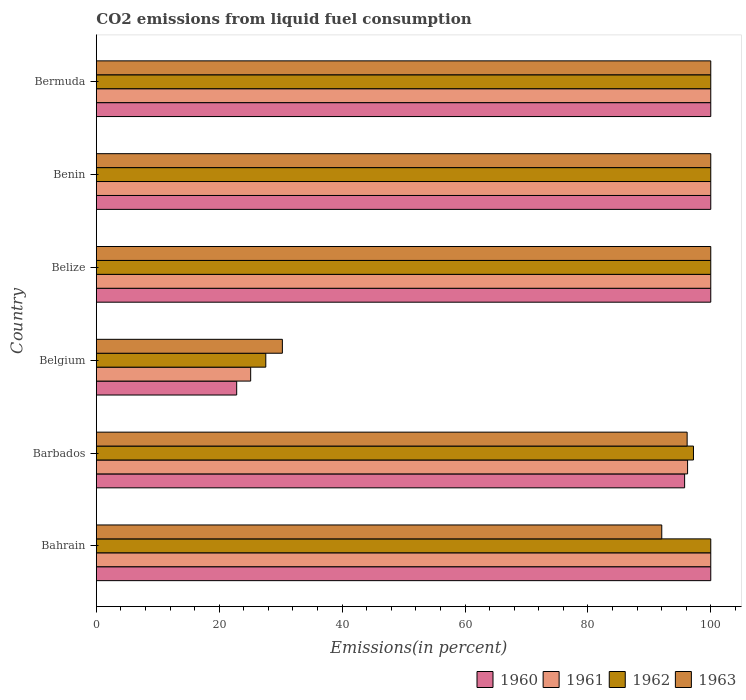How many groups of bars are there?
Your answer should be very brief. 6. Are the number of bars per tick equal to the number of legend labels?
Your answer should be very brief. Yes. Are the number of bars on each tick of the Y-axis equal?
Keep it short and to the point. Yes. How many bars are there on the 3rd tick from the bottom?
Make the answer very short. 4. What is the label of the 1st group of bars from the top?
Ensure brevity in your answer.  Bermuda. What is the total CO2 emitted in 1963 in Belgium?
Give a very brief answer. 30.28. Across all countries, what is the maximum total CO2 emitted in 1962?
Provide a succinct answer. 100. Across all countries, what is the minimum total CO2 emitted in 1961?
Your response must be concise. 25.12. In which country was the total CO2 emitted in 1961 maximum?
Make the answer very short. Bahrain. In which country was the total CO2 emitted in 1960 minimum?
Your response must be concise. Belgium. What is the total total CO2 emitted in 1963 in the graph?
Give a very brief answer. 518.46. What is the difference between the total CO2 emitted in 1961 in Barbados and that in Benin?
Your answer should be very brief. -3.77. What is the difference between the total CO2 emitted in 1961 in Bahrain and the total CO2 emitted in 1963 in Belgium?
Your answer should be compact. 69.72. What is the average total CO2 emitted in 1962 per country?
Provide a succinct answer. 87.46. What is the difference between the total CO2 emitted in 1960 and total CO2 emitted in 1963 in Belize?
Your answer should be compact. 0. In how many countries, is the total CO2 emitted in 1963 greater than 60 %?
Your answer should be compact. 5. What is the ratio of the total CO2 emitted in 1960 in Bahrain to that in Benin?
Offer a terse response. 1. Is the total CO2 emitted in 1960 in Belgium less than that in Belize?
Your answer should be very brief. Yes. Is the difference between the total CO2 emitted in 1960 in Bahrain and Belize greater than the difference between the total CO2 emitted in 1963 in Bahrain and Belize?
Keep it short and to the point. Yes. What is the difference between the highest and the second highest total CO2 emitted in 1960?
Make the answer very short. 0. What is the difference between the highest and the lowest total CO2 emitted in 1963?
Your answer should be compact. 69.72. In how many countries, is the total CO2 emitted in 1960 greater than the average total CO2 emitted in 1960 taken over all countries?
Offer a very short reply. 5. Is the sum of the total CO2 emitted in 1962 in Barbados and Belgium greater than the maximum total CO2 emitted in 1961 across all countries?
Offer a terse response. Yes. Is it the case that in every country, the sum of the total CO2 emitted in 1960 and total CO2 emitted in 1961 is greater than the sum of total CO2 emitted in 1963 and total CO2 emitted in 1962?
Make the answer very short. No. How many bars are there?
Your answer should be very brief. 24. Are the values on the major ticks of X-axis written in scientific E-notation?
Provide a succinct answer. No. Where does the legend appear in the graph?
Your answer should be very brief. Bottom right. How many legend labels are there?
Offer a terse response. 4. What is the title of the graph?
Offer a very short reply. CO2 emissions from liquid fuel consumption. What is the label or title of the X-axis?
Ensure brevity in your answer.  Emissions(in percent). What is the label or title of the Y-axis?
Give a very brief answer. Country. What is the Emissions(in percent) in 1960 in Bahrain?
Your answer should be very brief. 100. What is the Emissions(in percent) of 1961 in Bahrain?
Make the answer very short. 100. What is the Emissions(in percent) of 1962 in Bahrain?
Make the answer very short. 100. What is the Emissions(in percent) of 1963 in Bahrain?
Give a very brief answer. 92.02. What is the Emissions(in percent) in 1960 in Barbados?
Offer a terse response. 95.74. What is the Emissions(in percent) of 1961 in Barbados?
Keep it short and to the point. 96.23. What is the Emissions(in percent) of 1962 in Barbados?
Give a very brief answer. 97.18. What is the Emissions(in percent) of 1963 in Barbados?
Your response must be concise. 96.15. What is the Emissions(in percent) of 1960 in Belgium?
Offer a very short reply. 22.84. What is the Emissions(in percent) in 1961 in Belgium?
Offer a terse response. 25.12. What is the Emissions(in percent) in 1962 in Belgium?
Offer a very short reply. 27.58. What is the Emissions(in percent) in 1963 in Belgium?
Your response must be concise. 30.28. What is the Emissions(in percent) of 1960 in Belize?
Your answer should be compact. 100. What is the Emissions(in percent) in 1962 in Belize?
Provide a succinct answer. 100. What is the Emissions(in percent) of 1963 in Belize?
Your answer should be compact. 100. What is the Emissions(in percent) in 1961 in Benin?
Provide a succinct answer. 100. What is the Emissions(in percent) of 1962 in Benin?
Ensure brevity in your answer.  100. What is the Emissions(in percent) of 1960 in Bermuda?
Your answer should be very brief. 100. What is the Emissions(in percent) of 1961 in Bermuda?
Keep it short and to the point. 100. What is the Emissions(in percent) of 1962 in Bermuda?
Provide a short and direct response. 100. What is the Emissions(in percent) of 1963 in Bermuda?
Your answer should be very brief. 100. Across all countries, what is the maximum Emissions(in percent) of 1961?
Offer a very short reply. 100. Across all countries, what is the minimum Emissions(in percent) in 1960?
Your answer should be compact. 22.84. Across all countries, what is the minimum Emissions(in percent) of 1961?
Make the answer very short. 25.12. Across all countries, what is the minimum Emissions(in percent) in 1962?
Your answer should be very brief. 27.58. Across all countries, what is the minimum Emissions(in percent) in 1963?
Offer a terse response. 30.28. What is the total Emissions(in percent) in 1960 in the graph?
Ensure brevity in your answer.  518.58. What is the total Emissions(in percent) in 1961 in the graph?
Keep it short and to the point. 521.34. What is the total Emissions(in percent) in 1962 in the graph?
Offer a very short reply. 524.76. What is the total Emissions(in percent) in 1963 in the graph?
Give a very brief answer. 518.46. What is the difference between the Emissions(in percent) of 1960 in Bahrain and that in Barbados?
Offer a terse response. 4.26. What is the difference between the Emissions(in percent) in 1961 in Bahrain and that in Barbados?
Provide a short and direct response. 3.77. What is the difference between the Emissions(in percent) of 1962 in Bahrain and that in Barbados?
Provide a short and direct response. 2.82. What is the difference between the Emissions(in percent) of 1963 in Bahrain and that in Barbados?
Your answer should be very brief. -4.13. What is the difference between the Emissions(in percent) in 1960 in Bahrain and that in Belgium?
Offer a terse response. 77.16. What is the difference between the Emissions(in percent) in 1961 in Bahrain and that in Belgium?
Your answer should be compact. 74.88. What is the difference between the Emissions(in percent) of 1962 in Bahrain and that in Belgium?
Make the answer very short. 72.42. What is the difference between the Emissions(in percent) of 1963 in Bahrain and that in Belgium?
Provide a short and direct response. 61.75. What is the difference between the Emissions(in percent) of 1961 in Bahrain and that in Belize?
Make the answer very short. 0. What is the difference between the Emissions(in percent) in 1963 in Bahrain and that in Belize?
Keep it short and to the point. -7.98. What is the difference between the Emissions(in percent) in 1960 in Bahrain and that in Benin?
Keep it short and to the point. 0. What is the difference between the Emissions(in percent) of 1962 in Bahrain and that in Benin?
Offer a very short reply. 0. What is the difference between the Emissions(in percent) of 1963 in Bahrain and that in Benin?
Provide a short and direct response. -7.98. What is the difference between the Emissions(in percent) in 1960 in Bahrain and that in Bermuda?
Your answer should be very brief. 0. What is the difference between the Emissions(in percent) in 1963 in Bahrain and that in Bermuda?
Offer a very short reply. -7.98. What is the difference between the Emissions(in percent) in 1960 in Barbados and that in Belgium?
Make the answer very short. 72.9. What is the difference between the Emissions(in percent) of 1961 in Barbados and that in Belgium?
Ensure brevity in your answer.  71.11. What is the difference between the Emissions(in percent) in 1962 in Barbados and that in Belgium?
Offer a terse response. 69.61. What is the difference between the Emissions(in percent) in 1963 in Barbados and that in Belgium?
Make the answer very short. 65.88. What is the difference between the Emissions(in percent) in 1960 in Barbados and that in Belize?
Your answer should be compact. -4.26. What is the difference between the Emissions(in percent) in 1961 in Barbados and that in Belize?
Provide a succinct answer. -3.77. What is the difference between the Emissions(in percent) of 1962 in Barbados and that in Belize?
Give a very brief answer. -2.82. What is the difference between the Emissions(in percent) of 1963 in Barbados and that in Belize?
Your answer should be compact. -3.85. What is the difference between the Emissions(in percent) of 1960 in Barbados and that in Benin?
Provide a short and direct response. -4.26. What is the difference between the Emissions(in percent) in 1961 in Barbados and that in Benin?
Your response must be concise. -3.77. What is the difference between the Emissions(in percent) of 1962 in Barbados and that in Benin?
Offer a terse response. -2.82. What is the difference between the Emissions(in percent) of 1963 in Barbados and that in Benin?
Ensure brevity in your answer.  -3.85. What is the difference between the Emissions(in percent) of 1960 in Barbados and that in Bermuda?
Offer a terse response. -4.26. What is the difference between the Emissions(in percent) in 1961 in Barbados and that in Bermuda?
Give a very brief answer. -3.77. What is the difference between the Emissions(in percent) in 1962 in Barbados and that in Bermuda?
Your answer should be compact. -2.82. What is the difference between the Emissions(in percent) of 1963 in Barbados and that in Bermuda?
Provide a short and direct response. -3.85. What is the difference between the Emissions(in percent) in 1960 in Belgium and that in Belize?
Provide a succinct answer. -77.16. What is the difference between the Emissions(in percent) in 1961 in Belgium and that in Belize?
Your answer should be compact. -74.88. What is the difference between the Emissions(in percent) in 1962 in Belgium and that in Belize?
Your response must be concise. -72.42. What is the difference between the Emissions(in percent) of 1963 in Belgium and that in Belize?
Offer a terse response. -69.72. What is the difference between the Emissions(in percent) in 1960 in Belgium and that in Benin?
Give a very brief answer. -77.16. What is the difference between the Emissions(in percent) of 1961 in Belgium and that in Benin?
Provide a short and direct response. -74.88. What is the difference between the Emissions(in percent) in 1962 in Belgium and that in Benin?
Make the answer very short. -72.42. What is the difference between the Emissions(in percent) in 1963 in Belgium and that in Benin?
Your answer should be compact. -69.72. What is the difference between the Emissions(in percent) of 1960 in Belgium and that in Bermuda?
Give a very brief answer. -77.16. What is the difference between the Emissions(in percent) in 1961 in Belgium and that in Bermuda?
Provide a succinct answer. -74.88. What is the difference between the Emissions(in percent) of 1962 in Belgium and that in Bermuda?
Ensure brevity in your answer.  -72.42. What is the difference between the Emissions(in percent) of 1963 in Belgium and that in Bermuda?
Offer a very short reply. -69.72. What is the difference between the Emissions(in percent) of 1960 in Belize and that in Benin?
Provide a succinct answer. 0. What is the difference between the Emissions(in percent) of 1961 in Belize and that in Benin?
Offer a terse response. 0. What is the difference between the Emissions(in percent) of 1962 in Belize and that in Benin?
Provide a succinct answer. 0. What is the difference between the Emissions(in percent) of 1963 in Belize and that in Bermuda?
Your answer should be very brief. 0. What is the difference between the Emissions(in percent) in 1960 in Benin and that in Bermuda?
Offer a terse response. 0. What is the difference between the Emissions(in percent) of 1960 in Bahrain and the Emissions(in percent) of 1961 in Barbados?
Provide a succinct answer. 3.77. What is the difference between the Emissions(in percent) of 1960 in Bahrain and the Emissions(in percent) of 1962 in Barbados?
Provide a short and direct response. 2.82. What is the difference between the Emissions(in percent) in 1960 in Bahrain and the Emissions(in percent) in 1963 in Barbados?
Your answer should be very brief. 3.85. What is the difference between the Emissions(in percent) in 1961 in Bahrain and the Emissions(in percent) in 1962 in Barbados?
Provide a succinct answer. 2.82. What is the difference between the Emissions(in percent) of 1961 in Bahrain and the Emissions(in percent) of 1963 in Barbados?
Your response must be concise. 3.85. What is the difference between the Emissions(in percent) of 1962 in Bahrain and the Emissions(in percent) of 1963 in Barbados?
Your answer should be compact. 3.85. What is the difference between the Emissions(in percent) of 1960 in Bahrain and the Emissions(in percent) of 1961 in Belgium?
Your response must be concise. 74.88. What is the difference between the Emissions(in percent) of 1960 in Bahrain and the Emissions(in percent) of 1962 in Belgium?
Keep it short and to the point. 72.42. What is the difference between the Emissions(in percent) of 1960 in Bahrain and the Emissions(in percent) of 1963 in Belgium?
Your answer should be compact. 69.72. What is the difference between the Emissions(in percent) of 1961 in Bahrain and the Emissions(in percent) of 1962 in Belgium?
Make the answer very short. 72.42. What is the difference between the Emissions(in percent) of 1961 in Bahrain and the Emissions(in percent) of 1963 in Belgium?
Offer a terse response. 69.72. What is the difference between the Emissions(in percent) of 1962 in Bahrain and the Emissions(in percent) of 1963 in Belgium?
Ensure brevity in your answer.  69.72. What is the difference between the Emissions(in percent) in 1960 in Bahrain and the Emissions(in percent) in 1961 in Belize?
Provide a short and direct response. 0. What is the difference between the Emissions(in percent) in 1960 in Bahrain and the Emissions(in percent) in 1962 in Belize?
Keep it short and to the point. 0. What is the difference between the Emissions(in percent) in 1960 in Bahrain and the Emissions(in percent) in 1963 in Belize?
Keep it short and to the point. 0. What is the difference between the Emissions(in percent) of 1961 in Bahrain and the Emissions(in percent) of 1962 in Belize?
Your answer should be compact. 0. What is the difference between the Emissions(in percent) in 1962 in Bahrain and the Emissions(in percent) in 1963 in Belize?
Your answer should be very brief. 0. What is the difference between the Emissions(in percent) of 1962 in Bahrain and the Emissions(in percent) of 1963 in Benin?
Offer a terse response. 0. What is the difference between the Emissions(in percent) of 1961 in Bahrain and the Emissions(in percent) of 1963 in Bermuda?
Keep it short and to the point. 0. What is the difference between the Emissions(in percent) of 1962 in Bahrain and the Emissions(in percent) of 1963 in Bermuda?
Ensure brevity in your answer.  0. What is the difference between the Emissions(in percent) of 1960 in Barbados and the Emissions(in percent) of 1961 in Belgium?
Your response must be concise. 70.63. What is the difference between the Emissions(in percent) in 1960 in Barbados and the Emissions(in percent) in 1962 in Belgium?
Provide a succinct answer. 68.17. What is the difference between the Emissions(in percent) in 1960 in Barbados and the Emissions(in percent) in 1963 in Belgium?
Your response must be concise. 65.47. What is the difference between the Emissions(in percent) in 1961 in Barbados and the Emissions(in percent) in 1962 in Belgium?
Keep it short and to the point. 68.65. What is the difference between the Emissions(in percent) of 1961 in Barbados and the Emissions(in percent) of 1963 in Belgium?
Provide a short and direct response. 65.95. What is the difference between the Emissions(in percent) in 1962 in Barbados and the Emissions(in percent) in 1963 in Belgium?
Provide a succinct answer. 66.91. What is the difference between the Emissions(in percent) of 1960 in Barbados and the Emissions(in percent) of 1961 in Belize?
Ensure brevity in your answer.  -4.26. What is the difference between the Emissions(in percent) in 1960 in Barbados and the Emissions(in percent) in 1962 in Belize?
Your answer should be compact. -4.26. What is the difference between the Emissions(in percent) in 1960 in Barbados and the Emissions(in percent) in 1963 in Belize?
Your response must be concise. -4.26. What is the difference between the Emissions(in percent) in 1961 in Barbados and the Emissions(in percent) in 1962 in Belize?
Your answer should be very brief. -3.77. What is the difference between the Emissions(in percent) of 1961 in Barbados and the Emissions(in percent) of 1963 in Belize?
Provide a succinct answer. -3.77. What is the difference between the Emissions(in percent) of 1962 in Barbados and the Emissions(in percent) of 1963 in Belize?
Your answer should be very brief. -2.82. What is the difference between the Emissions(in percent) in 1960 in Barbados and the Emissions(in percent) in 1961 in Benin?
Offer a terse response. -4.26. What is the difference between the Emissions(in percent) of 1960 in Barbados and the Emissions(in percent) of 1962 in Benin?
Your answer should be compact. -4.26. What is the difference between the Emissions(in percent) of 1960 in Barbados and the Emissions(in percent) of 1963 in Benin?
Your answer should be compact. -4.26. What is the difference between the Emissions(in percent) of 1961 in Barbados and the Emissions(in percent) of 1962 in Benin?
Offer a very short reply. -3.77. What is the difference between the Emissions(in percent) of 1961 in Barbados and the Emissions(in percent) of 1963 in Benin?
Provide a short and direct response. -3.77. What is the difference between the Emissions(in percent) of 1962 in Barbados and the Emissions(in percent) of 1963 in Benin?
Your answer should be compact. -2.82. What is the difference between the Emissions(in percent) in 1960 in Barbados and the Emissions(in percent) in 1961 in Bermuda?
Offer a very short reply. -4.26. What is the difference between the Emissions(in percent) in 1960 in Barbados and the Emissions(in percent) in 1962 in Bermuda?
Give a very brief answer. -4.26. What is the difference between the Emissions(in percent) in 1960 in Barbados and the Emissions(in percent) in 1963 in Bermuda?
Your response must be concise. -4.26. What is the difference between the Emissions(in percent) in 1961 in Barbados and the Emissions(in percent) in 1962 in Bermuda?
Ensure brevity in your answer.  -3.77. What is the difference between the Emissions(in percent) of 1961 in Barbados and the Emissions(in percent) of 1963 in Bermuda?
Provide a succinct answer. -3.77. What is the difference between the Emissions(in percent) in 1962 in Barbados and the Emissions(in percent) in 1963 in Bermuda?
Offer a terse response. -2.82. What is the difference between the Emissions(in percent) of 1960 in Belgium and the Emissions(in percent) of 1961 in Belize?
Your answer should be very brief. -77.16. What is the difference between the Emissions(in percent) in 1960 in Belgium and the Emissions(in percent) in 1962 in Belize?
Your response must be concise. -77.16. What is the difference between the Emissions(in percent) of 1960 in Belgium and the Emissions(in percent) of 1963 in Belize?
Ensure brevity in your answer.  -77.16. What is the difference between the Emissions(in percent) in 1961 in Belgium and the Emissions(in percent) in 1962 in Belize?
Offer a very short reply. -74.88. What is the difference between the Emissions(in percent) in 1961 in Belgium and the Emissions(in percent) in 1963 in Belize?
Your answer should be compact. -74.88. What is the difference between the Emissions(in percent) of 1962 in Belgium and the Emissions(in percent) of 1963 in Belize?
Offer a very short reply. -72.42. What is the difference between the Emissions(in percent) in 1960 in Belgium and the Emissions(in percent) in 1961 in Benin?
Give a very brief answer. -77.16. What is the difference between the Emissions(in percent) in 1960 in Belgium and the Emissions(in percent) in 1962 in Benin?
Offer a very short reply. -77.16. What is the difference between the Emissions(in percent) in 1960 in Belgium and the Emissions(in percent) in 1963 in Benin?
Offer a terse response. -77.16. What is the difference between the Emissions(in percent) of 1961 in Belgium and the Emissions(in percent) of 1962 in Benin?
Your response must be concise. -74.88. What is the difference between the Emissions(in percent) of 1961 in Belgium and the Emissions(in percent) of 1963 in Benin?
Ensure brevity in your answer.  -74.88. What is the difference between the Emissions(in percent) of 1962 in Belgium and the Emissions(in percent) of 1963 in Benin?
Your response must be concise. -72.42. What is the difference between the Emissions(in percent) in 1960 in Belgium and the Emissions(in percent) in 1961 in Bermuda?
Keep it short and to the point. -77.16. What is the difference between the Emissions(in percent) in 1960 in Belgium and the Emissions(in percent) in 1962 in Bermuda?
Offer a very short reply. -77.16. What is the difference between the Emissions(in percent) of 1960 in Belgium and the Emissions(in percent) of 1963 in Bermuda?
Your answer should be compact. -77.16. What is the difference between the Emissions(in percent) in 1961 in Belgium and the Emissions(in percent) in 1962 in Bermuda?
Your answer should be very brief. -74.88. What is the difference between the Emissions(in percent) in 1961 in Belgium and the Emissions(in percent) in 1963 in Bermuda?
Your answer should be compact. -74.88. What is the difference between the Emissions(in percent) in 1962 in Belgium and the Emissions(in percent) in 1963 in Bermuda?
Your response must be concise. -72.42. What is the difference between the Emissions(in percent) in 1960 in Belize and the Emissions(in percent) in 1962 in Benin?
Ensure brevity in your answer.  0. What is the difference between the Emissions(in percent) in 1961 in Belize and the Emissions(in percent) in 1962 in Benin?
Offer a terse response. 0. What is the difference between the Emissions(in percent) in 1961 in Belize and the Emissions(in percent) in 1963 in Benin?
Your response must be concise. 0. What is the difference between the Emissions(in percent) of 1960 in Belize and the Emissions(in percent) of 1961 in Bermuda?
Give a very brief answer. 0. What is the difference between the Emissions(in percent) in 1960 in Belize and the Emissions(in percent) in 1962 in Bermuda?
Ensure brevity in your answer.  0. What is the difference between the Emissions(in percent) of 1960 in Belize and the Emissions(in percent) of 1963 in Bermuda?
Your answer should be very brief. 0. What is the difference between the Emissions(in percent) in 1961 in Belize and the Emissions(in percent) in 1963 in Bermuda?
Your answer should be compact. 0. What is the difference between the Emissions(in percent) in 1960 in Benin and the Emissions(in percent) in 1961 in Bermuda?
Offer a terse response. 0. What is the difference between the Emissions(in percent) of 1960 in Benin and the Emissions(in percent) of 1963 in Bermuda?
Keep it short and to the point. 0. What is the difference between the Emissions(in percent) of 1962 in Benin and the Emissions(in percent) of 1963 in Bermuda?
Your answer should be very brief. 0. What is the average Emissions(in percent) in 1960 per country?
Your response must be concise. 86.43. What is the average Emissions(in percent) of 1961 per country?
Give a very brief answer. 86.89. What is the average Emissions(in percent) of 1962 per country?
Your answer should be very brief. 87.46. What is the average Emissions(in percent) in 1963 per country?
Offer a terse response. 86.41. What is the difference between the Emissions(in percent) in 1960 and Emissions(in percent) in 1963 in Bahrain?
Provide a succinct answer. 7.98. What is the difference between the Emissions(in percent) in 1961 and Emissions(in percent) in 1962 in Bahrain?
Make the answer very short. 0. What is the difference between the Emissions(in percent) of 1961 and Emissions(in percent) of 1963 in Bahrain?
Ensure brevity in your answer.  7.98. What is the difference between the Emissions(in percent) of 1962 and Emissions(in percent) of 1963 in Bahrain?
Your answer should be very brief. 7.98. What is the difference between the Emissions(in percent) in 1960 and Emissions(in percent) in 1961 in Barbados?
Your response must be concise. -0.48. What is the difference between the Emissions(in percent) of 1960 and Emissions(in percent) of 1962 in Barbados?
Your answer should be compact. -1.44. What is the difference between the Emissions(in percent) in 1960 and Emissions(in percent) in 1963 in Barbados?
Your answer should be very brief. -0.41. What is the difference between the Emissions(in percent) in 1961 and Emissions(in percent) in 1962 in Barbados?
Ensure brevity in your answer.  -0.96. What is the difference between the Emissions(in percent) in 1961 and Emissions(in percent) in 1963 in Barbados?
Provide a short and direct response. 0.07. What is the difference between the Emissions(in percent) of 1962 and Emissions(in percent) of 1963 in Barbados?
Provide a short and direct response. 1.03. What is the difference between the Emissions(in percent) in 1960 and Emissions(in percent) in 1961 in Belgium?
Make the answer very short. -2.28. What is the difference between the Emissions(in percent) of 1960 and Emissions(in percent) of 1962 in Belgium?
Provide a succinct answer. -4.74. What is the difference between the Emissions(in percent) of 1960 and Emissions(in percent) of 1963 in Belgium?
Ensure brevity in your answer.  -7.44. What is the difference between the Emissions(in percent) in 1961 and Emissions(in percent) in 1962 in Belgium?
Ensure brevity in your answer.  -2.46. What is the difference between the Emissions(in percent) in 1961 and Emissions(in percent) in 1963 in Belgium?
Ensure brevity in your answer.  -5.16. What is the difference between the Emissions(in percent) in 1962 and Emissions(in percent) in 1963 in Belgium?
Your answer should be compact. -2.7. What is the difference between the Emissions(in percent) of 1960 and Emissions(in percent) of 1962 in Belize?
Provide a succinct answer. 0. What is the difference between the Emissions(in percent) in 1961 and Emissions(in percent) in 1962 in Belize?
Provide a succinct answer. 0. What is the difference between the Emissions(in percent) in 1961 and Emissions(in percent) in 1963 in Belize?
Offer a very short reply. 0. What is the difference between the Emissions(in percent) in 1960 and Emissions(in percent) in 1962 in Benin?
Provide a short and direct response. 0. What is the difference between the Emissions(in percent) in 1961 and Emissions(in percent) in 1962 in Benin?
Keep it short and to the point. 0. What is the difference between the Emissions(in percent) of 1961 and Emissions(in percent) of 1963 in Benin?
Your response must be concise. 0. What is the difference between the Emissions(in percent) of 1962 and Emissions(in percent) of 1963 in Benin?
Offer a very short reply. 0. What is the difference between the Emissions(in percent) in 1960 and Emissions(in percent) in 1961 in Bermuda?
Make the answer very short. 0. What is the difference between the Emissions(in percent) in 1961 and Emissions(in percent) in 1962 in Bermuda?
Provide a succinct answer. 0. What is the difference between the Emissions(in percent) in 1961 and Emissions(in percent) in 1963 in Bermuda?
Give a very brief answer. 0. What is the ratio of the Emissions(in percent) in 1960 in Bahrain to that in Barbados?
Your response must be concise. 1.04. What is the ratio of the Emissions(in percent) in 1961 in Bahrain to that in Barbados?
Provide a succinct answer. 1.04. What is the ratio of the Emissions(in percent) in 1962 in Bahrain to that in Barbados?
Give a very brief answer. 1.03. What is the ratio of the Emissions(in percent) in 1963 in Bahrain to that in Barbados?
Keep it short and to the point. 0.96. What is the ratio of the Emissions(in percent) of 1960 in Bahrain to that in Belgium?
Offer a terse response. 4.38. What is the ratio of the Emissions(in percent) in 1961 in Bahrain to that in Belgium?
Offer a very short reply. 3.98. What is the ratio of the Emissions(in percent) in 1962 in Bahrain to that in Belgium?
Your response must be concise. 3.63. What is the ratio of the Emissions(in percent) of 1963 in Bahrain to that in Belgium?
Provide a succinct answer. 3.04. What is the ratio of the Emissions(in percent) of 1960 in Bahrain to that in Belize?
Make the answer very short. 1. What is the ratio of the Emissions(in percent) of 1961 in Bahrain to that in Belize?
Make the answer very short. 1. What is the ratio of the Emissions(in percent) in 1963 in Bahrain to that in Belize?
Offer a terse response. 0.92. What is the ratio of the Emissions(in percent) of 1960 in Bahrain to that in Benin?
Offer a very short reply. 1. What is the ratio of the Emissions(in percent) in 1963 in Bahrain to that in Benin?
Your response must be concise. 0.92. What is the ratio of the Emissions(in percent) in 1961 in Bahrain to that in Bermuda?
Provide a short and direct response. 1. What is the ratio of the Emissions(in percent) in 1962 in Bahrain to that in Bermuda?
Ensure brevity in your answer.  1. What is the ratio of the Emissions(in percent) in 1963 in Bahrain to that in Bermuda?
Your answer should be compact. 0.92. What is the ratio of the Emissions(in percent) in 1960 in Barbados to that in Belgium?
Provide a succinct answer. 4.19. What is the ratio of the Emissions(in percent) in 1961 in Barbados to that in Belgium?
Your response must be concise. 3.83. What is the ratio of the Emissions(in percent) in 1962 in Barbados to that in Belgium?
Offer a very short reply. 3.52. What is the ratio of the Emissions(in percent) of 1963 in Barbados to that in Belgium?
Provide a short and direct response. 3.18. What is the ratio of the Emissions(in percent) of 1960 in Barbados to that in Belize?
Provide a succinct answer. 0.96. What is the ratio of the Emissions(in percent) of 1961 in Barbados to that in Belize?
Offer a very short reply. 0.96. What is the ratio of the Emissions(in percent) in 1962 in Barbados to that in Belize?
Make the answer very short. 0.97. What is the ratio of the Emissions(in percent) of 1963 in Barbados to that in Belize?
Provide a succinct answer. 0.96. What is the ratio of the Emissions(in percent) of 1960 in Barbados to that in Benin?
Your response must be concise. 0.96. What is the ratio of the Emissions(in percent) in 1961 in Barbados to that in Benin?
Provide a short and direct response. 0.96. What is the ratio of the Emissions(in percent) of 1962 in Barbados to that in Benin?
Keep it short and to the point. 0.97. What is the ratio of the Emissions(in percent) of 1963 in Barbados to that in Benin?
Your answer should be compact. 0.96. What is the ratio of the Emissions(in percent) in 1960 in Barbados to that in Bermuda?
Provide a succinct answer. 0.96. What is the ratio of the Emissions(in percent) in 1961 in Barbados to that in Bermuda?
Provide a succinct answer. 0.96. What is the ratio of the Emissions(in percent) in 1962 in Barbados to that in Bermuda?
Offer a very short reply. 0.97. What is the ratio of the Emissions(in percent) in 1963 in Barbados to that in Bermuda?
Give a very brief answer. 0.96. What is the ratio of the Emissions(in percent) in 1960 in Belgium to that in Belize?
Offer a terse response. 0.23. What is the ratio of the Emissions(in percent) in 1961 in Belgium to that in Belize?
Your response must be concise. 0.25. What is the ratio of the Emissions(in percent) in 1962 in Belgium to that in Belize?
Provide a succinct answer. 0.28. What is the ratio of the Emissions(in percent) in 1963 in Belgium to that in Belize?
Provide a succinct answer. 0.3. What is the ratio of the Emissions(in percent) of 1960 in Belgium to that in Benin?
Provide a succinct answer. 0.23. What is the ratio of the Emissions(in percent) of 1961 in Belgium to that in Benin?
Offer a very short reply. 0.25. What is the ratio of the Emissions(in percent) in 1962 in Belgium to that in Benin?
Ensure brevity in your answer.  0.28. What is the ratio of the Emissions(in percent) in 1963 in Belgium to that in Benin?
Ensure brevity in your answer.  0.3. What is the ratio of the Emissions(in percent) in 1960 in Belgium to that in Bermuda?
Provide a succinct answer. 0.23. What is the ratio of the Emissions(in percent) in 1961 in Belgium to that in Bermuda?
Provide a succinct answer. 0.25. What is the ratio of the Emissions(in percent) in 1962 in Belgium to that in Bermuda?
Make the answer very short. 0.28. What is the ratio of the Emissions(in percent) of 1963 in Belgium to that in Bermuda?
Give a very brief answer. 0.3. What is the ratio of the Emissions(in percent) of 1960 in Belize to that in Bermuda?
Offer a terse response. 1. What is the ratio of the Emissions(in percent) of 1960 in Benin to that in Bermuda?
Provide a short and direct response. 1. What is the ratio of the Emissions(in percent) in 1961 in Benin to that in Bermuda?
Your answer should be compact. 1. What is the ratio of the Emissions(in percent) in 1962 in Benin to that in Bermuda?
Provide a succinct answer. 1. What is the ratio of the Emissions(in percent) of 1963 in Benin to that in Bermuda?
Provide a succinct answer. 1. What is the difference between the highest and the second highest Emissions(in percent) of 1960?
Provide a short and direct response. 0. What is the difference between the highest and the second highest Emissions(in percent) of 1961?
Provide a short and direct response. 0. What is the difference between the highest and the second highest Emissions(in percent) of 1962?
Your answer should be very brief. 0. What is the difference between the highest and the lowest Emissions(in percent) of 1960?
Make the answer very short. 77.16. What is the difference between the highest and the lowest Emissions(in percent) of 1961?
Your response must be concise. 74.88. What is the difference between the highest and the lowest Emissions(in percent) of 1962?
Ensure brevity in your answer.  72.42. What is the difference between the highest and the lowest Emissions(in percent) in 1963?
Offer a very short reply. 69.72. 